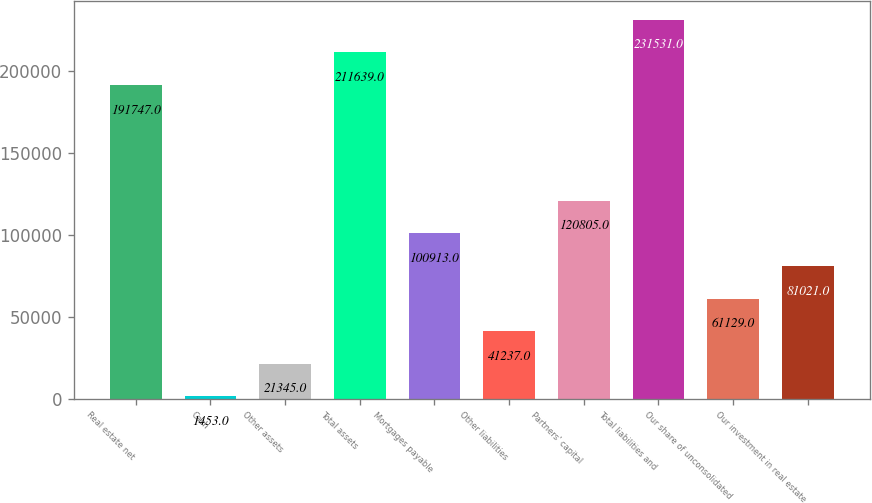Convert chart. <chart><loc_0><loc_0><loc_500><loc_500><bar_chart><fcel>Real estate net<fcel>Cash<fcel>Other assets<fcel>Total assets<fcel>Mortgages payable<fcel>Other liabilities<fcel>Partners' capital<fcel>Total liabilities and<fcel>Our share of unconsolidated<fcel>Our investment in real estate<nl><fcel>191747<fcel>1453<fcel>21345<fcel>211639<fcel>100913<fcel>41237<fcel>120805<fcel>231531<fcel>61129<fcel>81021<nl></chart> 